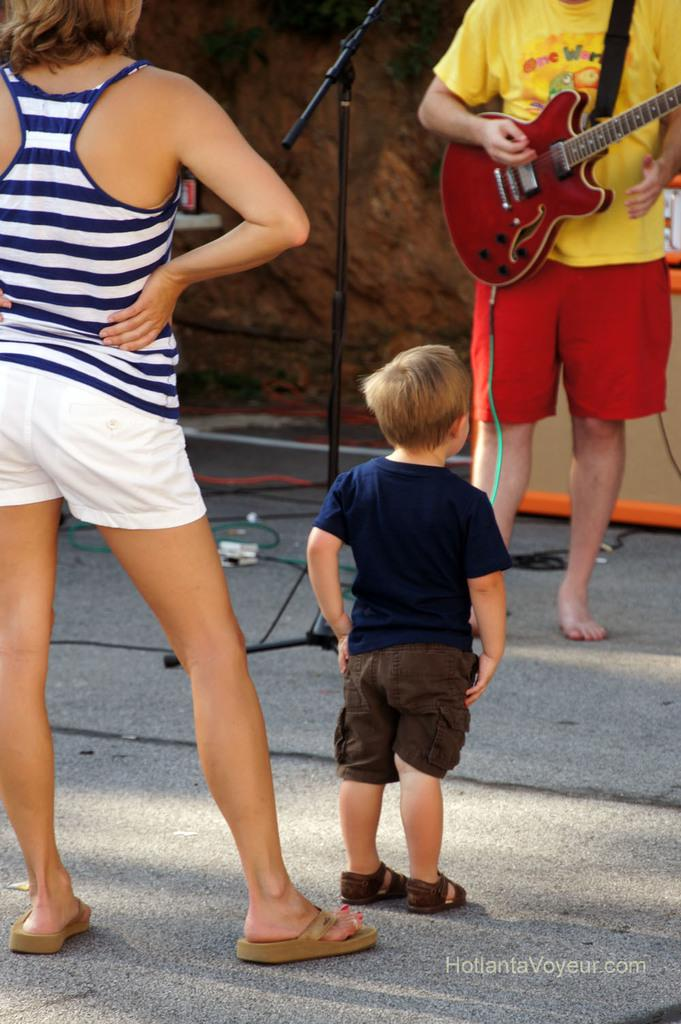What is the woman doing in the image? The woman is standing in the image. What is the boy's position in relation to the woman? The boy is in front of the woman. Who are the woman and the boy looking at? They are looking at a person who is playing a guitar. What instrument is the person playing? The person is playing a guitar. What object is present for amplifying sound? There is a microphone stand in the image. What is the background of the image made of? There is a wall in the image. What else can be seen in the image? There are wires visible in the image. How many feet are visible on the sheet in the image? There is no sheet or feet present in the image. What invention is being demonstrated by the person in the image? The person is playing a guitar, but there is no invention being demonstrated in the image. 